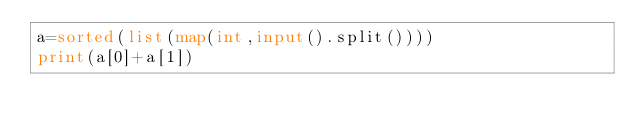Convert code to text. <code><loc_0><loc_0><loc_500><loc_500><_Python_>a=sorted(list(map(int,input().split())))
print(a[0]+a[1])</code> 